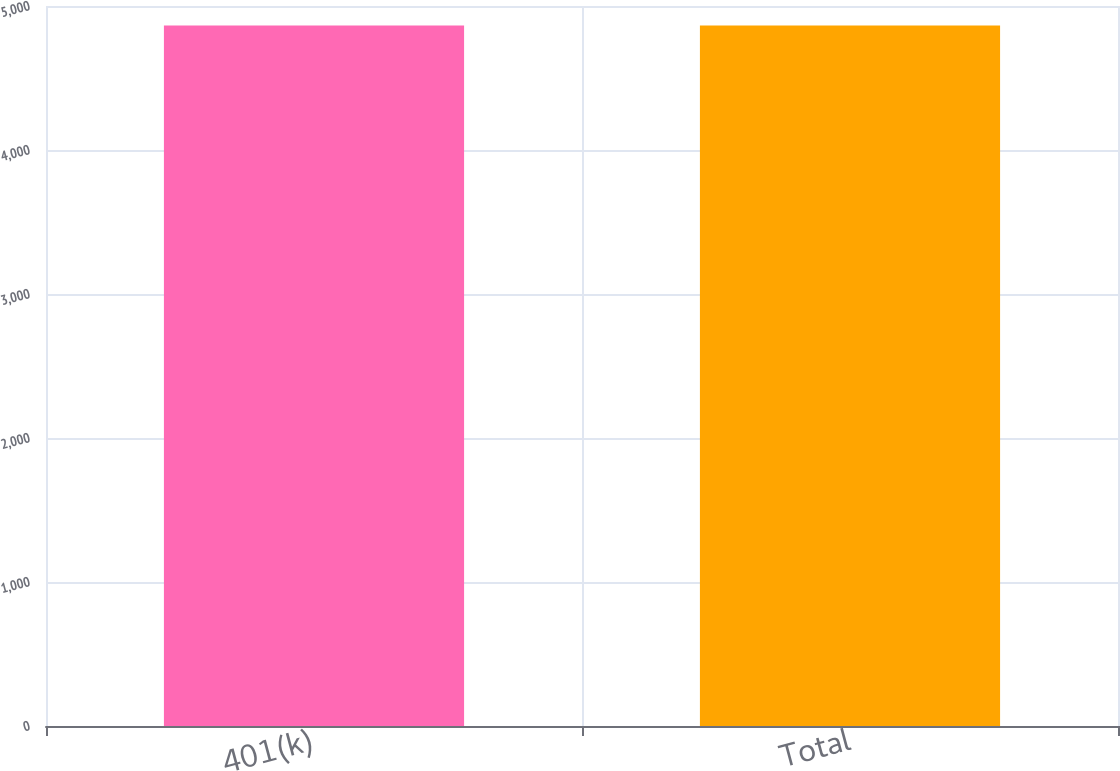<chart> <loc_0><loc_0><loc_500><loc_500><bar_chart><fcel>401(k)<fcel>Total<nl><fcel>4865<fcel>4865.1<nl></chart> 